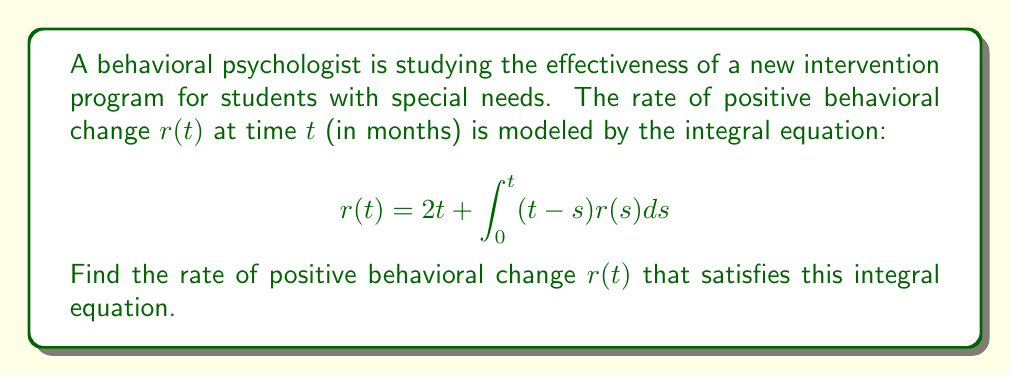Show me your answer to this math problem. To solve this integral equation, we'll use the method of differentiating both sides:

1) First, differentiate both sides of the equation with respect to $t$:

   $$\frac{d}{dt}r(t) = 2 + \frac{d}{dt}\int_0^t (t-s)r(s)ds$$

2) Apply the Leibniz rule to differentiate the integral:

   $$\frac{d}{dt}r(t) = 2 + \int_0^t \frac{\partial}{\partial t}(t-s)r(s)ds + (t-t)r(t)$$

3) Simplify:

   $$\frac{d}{dt}r(t) = 2 + \int_0^t r(s)ds$$

4) Differentiate again:

   $$\frac{d^2}{dt^2}r(t) = r(t)$$

5) This is a second-order linear differential equation. The general solution is:

   $$r(t) = C_1e^t + C_2e^{-t}$$

6) To find $C_1$ and $C_2$, use the initial conditions:

   At $t=0$: $r(0) = 0$, so $C_1 + C_2 = 0$

   At $t=0$: $r'(0) = 2$, so $C_1 - C_2 = 2$

7) Solve these equations:

   $C_1 = 1$ and $C_2 = -1$

8) Therefore, the solution is:

   $$r(t) = e^t - e^{-t} = 2\sinh(t)$$

9) Verify this solution satisfies the original equation:

   $$2\sinh(t) = 2t + \int_0^t (t-s)(2\sinh(s))ds$$

   $$2\sinh(t) = 2t + 2t\sinh(t) - 2(\cosh(t)-1)$$

   $$2\sinh(t) = 2t + 2t\sinh(t) - 2\cosh(t) + 2$$

   This is indeed true for all $t$, confirming our solution.
Answer: $r(t) = 2\sinh(t)$ 